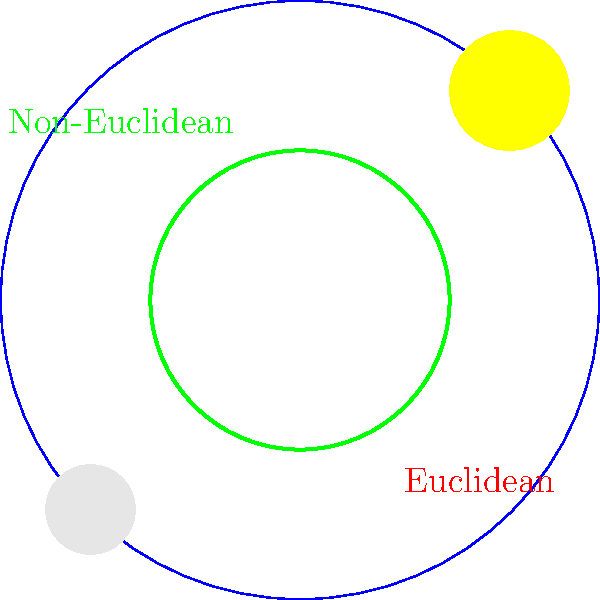In the diagram, a Euclidean circle (red) and a non-Euclidean circle on a sphere (green) are shown, both with the same radius $r$. If the radius is small compared to the sphere's radius $R$, how does the area of the non-Euclidean circle $A_{NE}$ compare to the area of the Euclidean circle $A_E$? Express your answer as a ratio $\frac{A_{NE}}{A_E}$ in terms of $r$ and $R$. Let's approach this step-by-step:

1) The area of a Euclidean circle is given by:
   $$A_E = \pi r^2$$

2) For a small circle on a sphere (non-Euclidean), the area is approximately:
   $$A_{NE} \approx \pi r^2 (1 + \frac{r^2}{4R^2})$$

3) This formula comes from the Taylor expansion of the exact formula for the area of a spherical cap.

4) To find the ratio, we divide $A_{NE}$ by $A_E$:

   $$\frac{A_{NE}}{A_E} = \frac{\pi r^2 (1 + \frac{r^2}{4R^2})}{\pi r^2}$$

5) The $\pi r^2$ terms cancel out:

   $$\frac{A_{NE}}{A_E} = 1 + \frac{r^2}{4R^2}$$

6) This shows that the non-Euclidean circle has a slightly larger area than its Euclidean counterpart.

7) The sun and moon in the diagram represent the curvature of the sphere, reminiscent of the celestial sphere observed in nature.
Answer: $1 + \frac{r^2}{4R^2}$ 